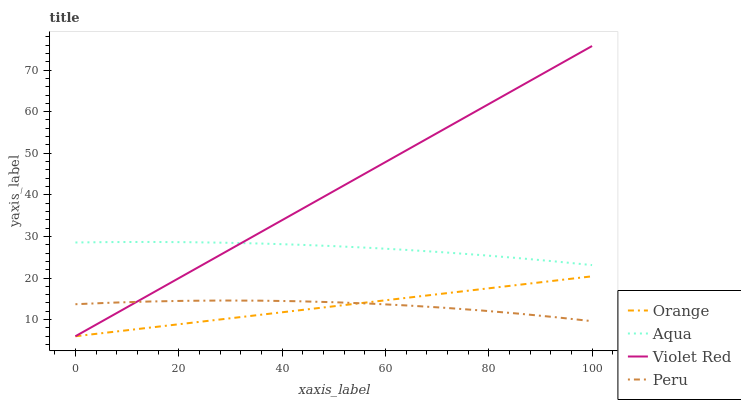Does Orange have the minimum area under the curve?
Answer yes or no. Yes. Does Violet Red have the maximum area under the curve?
Answer yes or no. Yes. Does Aqua have the minimum area under the curve?
Answer yes or no. No. Does Aqua have the maximum area under the curve?
Answer yes or no. No. Is Orange the smoothest?
Answer yes or no. Yes. Is Peru the roughest?
Answer yes or no. Yes. Is Violet Red the smoothest?
Answer yes or no. No. Is Violet Red the roughest?
Answer yes or no. No. Does Orange have the lowest value?
Answer yes or no. Yes. Does Aqua have the lowest value?
Answer yes or no. No. Does Violet Red have the highest value?
Answer yes or no. Yes. Does Aqua have the highest value?
Answer yes or no. No. Is Orange less than Aqua?
Answer yes or no. Yes. Is Aqua greater than Peru?
Answer yes or no. Yes. Does Aqua intersect Violet Red?
Answer yes or no. Yes. Is Aqua less than Violet Red?
Answer yes or no. No. Is Aqua greater than Violet Red?
Answer yes or no. No. Does Orange intersect Aqua?
Answer yes or no. No. 